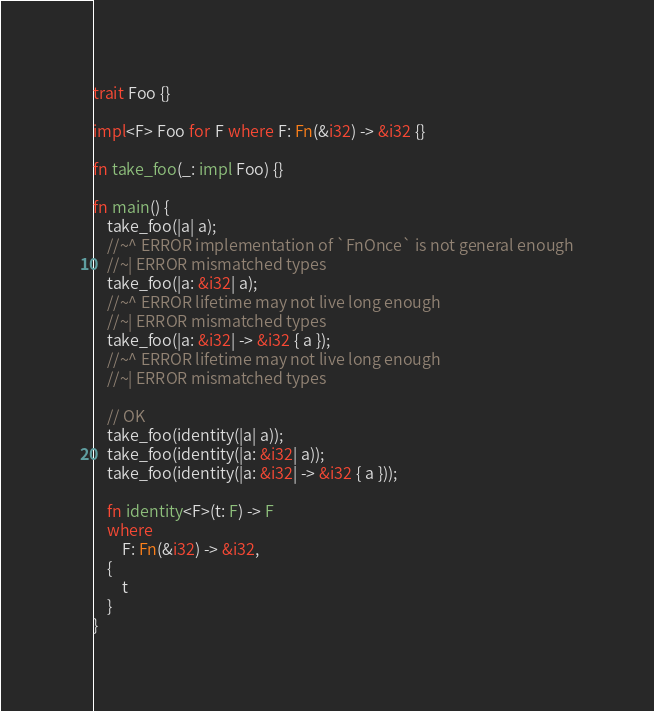Convert code to text. <code><loc_0><loc_0><loc_500><loc_500><_Rust_>trait Foo {}

impl<F> Foo for F where F: Fn(&i32) -> &i32 {}

fn take_foo(_: impl Foo) {}

fn main() {
    take_foo(|a| a);
    //~^ ERROR implementation of `FnOnce` is not general enough
    //~| ERROR mismatched types
    take_foo(|a: &i32| a);
    //~^ ERROR lifetime may not live long enough
    //~| ERROR mismatched types
    take_foo(|a: &i32| -> &i32 { a });
    //~^ ERROR lifetime may not live long enough
    //~| ERROR mismatched types

    // OK
    take_foo(identity(|a| a));
    take_foo(identity(|a: &i32| a));
    take_foo(identity(|a: &i32| -> &i32 { a }));

    fn identity<F>(t: F) -> F
    where
        F: Fn(&i32) -> &i32,
    {
        t
    }
}
</code> 